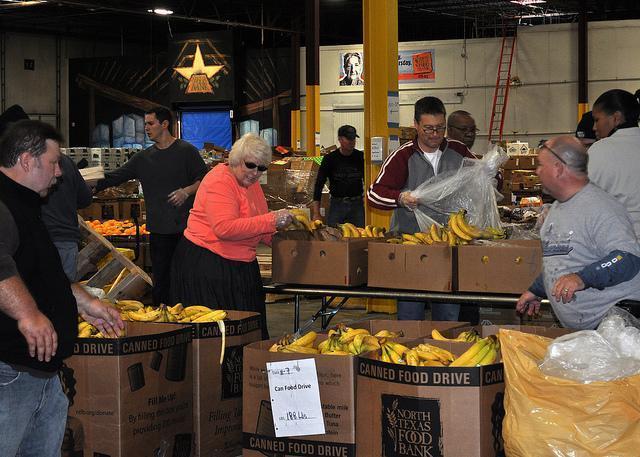How many boxes of bananas are there?
Give a very brief answer. 7. How many people are visible?
Give a very brief answer. 8. 